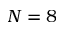<formula> <loc_0><loc_0><loc_500><loc_500>N = 8</formula> 